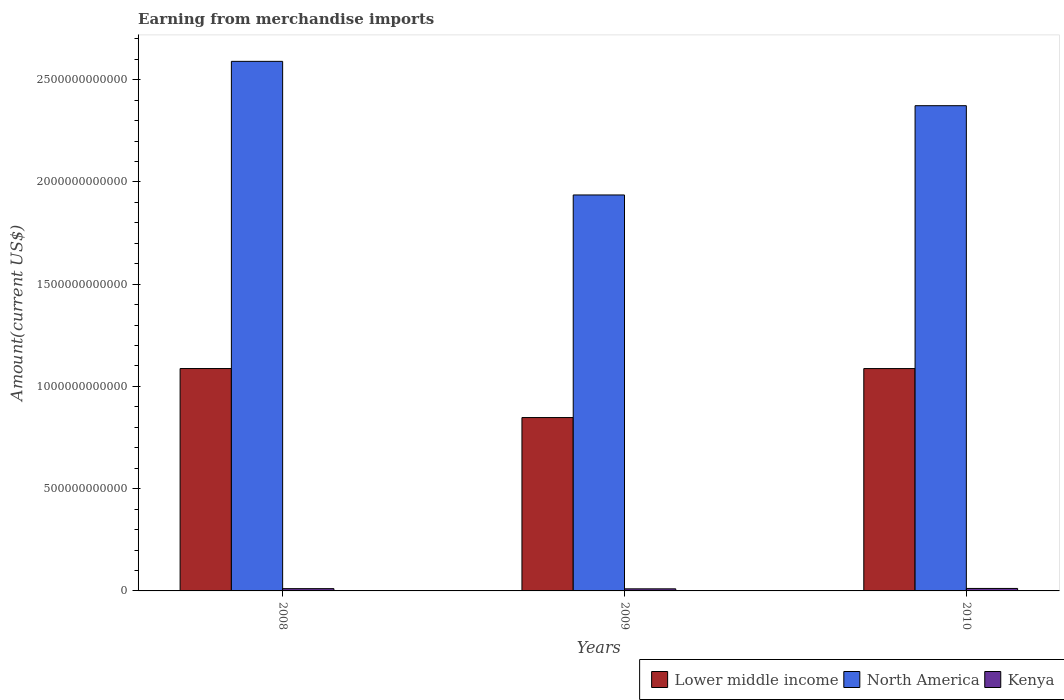Are the number of bars on each tick of the X-axis equal?
Provide a short and direct response. Yes. How many bars are there on the 3rd tick from the right?
Your response must be concise. 3. What is the amount earned from merchandise imports in North America in 2010?
Offer a very short reply. 2.37e+12. Across all years, what is the maximum amount earned from merchandise imports in Lower middle income?
Your answer should be very brief. 1.09e+12. Across all years, what is the minimum amount earned from merchandise imports in Lower middle income?
Give a very brief answer. 8.48e+11. In which year was the amount earned from merchandise imports in Lower middle income minimum?
Give a very brief answer. 2009. What is the total amount earned from merchandise imports in North America in the graph?
Keep it short and to the point. 6.90e+12. What is the difference between the amount earned from merchandise imports in Lower middle income in 2008 and that in 2010?
Your response must be concise. 1.57e+08. What is the difference between the amount earned from merchandise imports in Kenya in 2010 and the amount earned from merchandise imports in Lower middle income in 2009?
Your answer should be compact. -8.36e+11. What is the average amount earned from merchandise imports in Lower middle income per year?
Make the answer very short. 1.01e+12. In the year 2009, what is the difference between the amount earned from merchandise imports in Kenya and amount earned from merchandise imports in Lower middle income?
Provide a short and direct response. -8.38e+11. What is the ratio of the amount earned from merchandise imports in Lower middle income in 2009 to that in 2010?
Your answer should be very brief. 0.78. Is the amount earned from merchandise imports in Lower middle income in 2009 less than that in 2010?
Your response must be concise. Yes. Is the difference between the amount earned from merchandise imports in Kenya in 2008 and 2009 greater than the difference between the amount earned from merchandise imports in Lower middle income in 2008 and 2009?
Offer a very short reply. No. What is the difference between the highest and the second highest amount earned from merchandise imports in Lower middle income?
Your answer should be compact. 1.57e+08. What is the difference between the highest and the lowest amount earned from merchandise imports in Kenya?
Ensure brevity in your answer.  1.89e+09. In how many years, is the amount earned from merchandise imports in Kenya greater than the average amount earned from merchandise imports in Kenya taken over all years?
Your response must be concise. 1. Is the sum of the amount earned from merchandise imports in Lower middle income in 2008 and 2009 greater than the maximum amount earned from merchandise imports in Kenya across all years?
Your response must be concise. Yes. What does the 1st bar from the left in 2010 represents?
Provide a short and direct response. Lower middle income. What does the 3rd bar from the right in 2008 represents?
Provide a short and direct response. Lower middle income. Is it the case that in every year, the sum of the amount earned from merchandise imports in North America and amount earned from merchandise imports in Lower middle income is greater than the amount earned from merchandise imports in Kenya?
Your response must be concise. Yes. How many bars are there?
Your response must be concise. 9. Are all the bars in the graph horizontal?
Your answer should be very brief. No. What is the difference between two consecutive major ticks on the Y-axis?
Your response must be concise. 5.00e+11. Does the graph contain any zero values?
Offer a very short reply. No. How many legend labels are there?
Ensure brevity in your answer.  3. What is the title of the graph?
Keep it short and to the point. Earning from merchandise imports. What is the label or title of the X-axis?
Your answer should be compact. Years. What is the label or title of the Y-axis?
Offer a very short reply. Amount(current US$). What is the Amount(current US$) in Lower middle income in 2008?
Keep it short and to the point. 1.09e+12. What is the Amount(current US$) in North America in 2008?
Make the answer very short. 2.59e+12. What is the Amount(current US$) in Kenya in 2008?
Your answer should be very brief. 1.11e+1. What is the Amount(current US$) of Lower middle income in 2009?
Offer a very short reply. 8.48e+11. What is the Amount(current US$) in North America in 2009?
Provide a succinct answer. 1.94e+12. What is the Amount(current US$) of Kenya in 2009?
Give a very brief answer. 1.02e+1. What is the Amount(current US$) of Lower middle income in 2010?
Keep it short and to the point. 1.09e+12. What is the Amount(current US$) in North America in 2010?
Offer a very short reply. 2.37e+12. What is the Amount(current US$) of Kenya in 2010?
Provide a succinct answer. 1.21e+1. Across all years, what is the maximum Amount(current US$) in Lower middle income?
Ensure brevity in your answer.  1.09e+12. Across all years, what is the maximum Amount(current US$) of North America?
Your response must be concise. 2.59e+12. Across all years, what is the maximum Amount(current US$) in Kenya?
Your answer should be very brief. 1.21e+1. Across all years, what is the minimum Amount(current US$) of Lower middle income?
Give a very brief answer. 8.48e+11. Across all years, what is the minimum Amount(current US$) in North America?
Offer a very short reply. 1.94e+12. Across all years, what is the minimum Amount(current US$) of Kenya?
Your answer should be compact. 1.02e+1. What is the total Amount(current US$) in Lower middle income in the graph?
Give a very brief answer. 3.02e+12. What is the total Amount(current US$) in North America in the graph?
Offer a very short reply. 6.90e+12. What is the total Amount(current US$) of Kenya in the graph?
Make the answer very short. 3.34e+1. What is the difference between the Amount(current US$) of Lower middle income in 2008 and that in 2009?
Provide a succinct answer. 2.40e+11. What is the difference between the Amount(current US$) in North America in 2008 and that in 2009?
Provide a short and direct response. 6.53e+11. What is the difference between the Amount(current US$) in Kenya in 2008 and that in 2009?
Offer a very short reply. 9.26e+08. What is the difference between the Amount(current US$) in Lower middle income in 2008 and that in 2010?
Your response must be concise. 1.57e+08. What is the difference between the Amount(current US$) in North America in 2008 and that in 2010?
Provide a short and direct response. 2.17e+11. What is the difference between the Amount(current US$) of Kenya in 2008 and that in 2010?
Your answer should be compact. -9.65e+08. What is the difference between the Amount(current US$) of Lower middle income in 2009 and that in 2010?
Your answer should be very brief. -2.40e+11. What is the difference between the Amount(current US$) in North America in 2009 and that in 2010?
Offer a very short reply. -4.37e+11. What is the difference between the Amount(current US$) in Kenya in 2009 and that in 2010?
Your response must be concise. -1.89e+09. What is the difference between the Amount(current US$) of Lower middle income in 2008 and the Amount(current US$) of North America in 2009?
Make the answer very short. -8.49e+11. What is the difference between the Amount(current US$) in Lower middle income in 2008 and the Amount(current US$) in Kenya in 2009?
Your answer should be compact. 1.08e+12. What is the difference between the Amount(current US$) in North America in 2008 and the Amount(current US$) in Kenya in 2009?
Your answer should be very brief. 2.58e+12. What is the difference between the Amount(current US$) of Lower middle income in 2008 and the Amount(current US$) of North America in 2010?
Keep it short and to the point. -1.29e+12. What is the difference between the Amount(current US$) in Lower middle income in 2008 and the Amount(current US$) in Kenya in 2010?
Offer a very short reply. 1.08e+12. What is the difference between the Amount(current US$) in North America in 2008 and the Amount(current US$) in Kenya in 2010?
Offer a terse response. 2.58e+12. What is the difference between the Amount(current US$) of Lower middle income in 2009 and the Amount(current US$) of North America in 2010?
Provide a short and direct response. -1.53e+12. What is the difference between the Amount(current US$) in Lower middle income in 2009 and the Amount(current US$) in Kenya in 2010?
Keep it short and to the point. 8.36e+11. What is the difference between the Amount(current US$) in North America in 2009 and the Amount(current US$) in Kenya in 2010?
Your answer should be compact. 1.92e+12. What is the average Amount(current US$) of Lower middle income per year?
Provide a succinct answer. 1.01e+12. What is the average Amount(current US$) of North America per year?
Provide a short and direct response. 2.30e+12. What is the average Amount(current US$) in Kenya per year?
Your answer should be compact. 1.11e+1. In the year 2008, what is the difference between the Amount(current US$) of Lower middle income and Amount(current US$) of North America?
Your answer should be very brief. -1.50e+12. In the year 2008, what is the difference between the Amount(current US$) of Lower middle income and Amount(current US$) of Kenya?
Provide a short and direct response. 1.08e+12. In the year 2008, what is the difference between the Amount(current US$) in North America and Amount(current US$) in Kenya?
Ensure brevity in your answer.  2.58e+12. In the year 2009, what is the difference between the Amount(current US$) in Lower middle income and Amount(current US$) in North America?
Keep it short and to the point. -1.09e+12. In the year 2009, what is the difference between the Amount(current US$) in Lower middle income and Amount(current US$) in Kenya?
Your answer should be compact. 8.38e+11. In the year 2009, what is the difference between the Amount(current US$) in North America and Amount(current US$) in Kenya?
Make the answer very short. 1.93e+12. In the year 2010, what is the difference between the Amount(current US$) in Lower middle income and Amount(current US$) in North America?
Your answer should be very brief. -1.29e+12. In the year 2010, what is the difference between the Amount(current US$) of Lower middle income and Amount(current US$) of Kenya?
Make the answer very short. 1.08e+12. In the year 2010, what is the difference between the Amount(current US$) in North America and Amount(current US$) in Kenya?
Provide a short and direct response. 2.36e+12. What is the ratio of the Amount(current US$) in Lower middle income in 2008 to that in 2009?
Your answer should be compact. 1.28. What is the ratio of the Amount(current US$) in North America in 2008 to that in 2009?
Your answer should be very brief. 1.34. What is the ratio of the Amount(current US$) of Kenya in 2008 to that in 2009?
Give a very brief answer. 1.09. What is the ratio of the Amount(current US$) of North America in 2008 to that in 2010?
Provide a short and direct response. 1.09. What is the ratio of the Amount(current US$) in Kenya in 2008 to that in 2010?
Ensure brevity in your answer.  0.92. What is the ratio of the Amount(current US$) in Lower middle income in 2009 to that in 2010?
Provide a short and direct response. 0.78. What is the ratio of the Amount(current US$) of North America in 2009 to that in 2010?
Offer a very short reply. 0.82. What is the ratio of the Amount(current US$) of Kenya in 2009 to that in 2010?
Ensure brevity in your answer.  0.84. What is the difference between the highest and the second highest Amount(current US$) of Lower middle income?
Your response must be concise. 1.57e+08. What is the difference between the highest and the second highest Amount(current US$) of North America?
Give a very brief answer. 2.17e+11. What is the difference between the highest and the second highest Amount(current US$) in Kenya?
Give a very brief answer. 9.65e+08. What is the difference between the highest and the lowest Amount(current US$) of Lower middle income?
Your response must be concise. 2.40e+11. What is the difference between the highest and the lowest Amount(current US$) of North America?
Give a very brief answer. 6.53e+11. What is the difference between the highest and the lowest Amount(current US$) of Kenya?
Provide a short and direct response. 1.89e+09. 